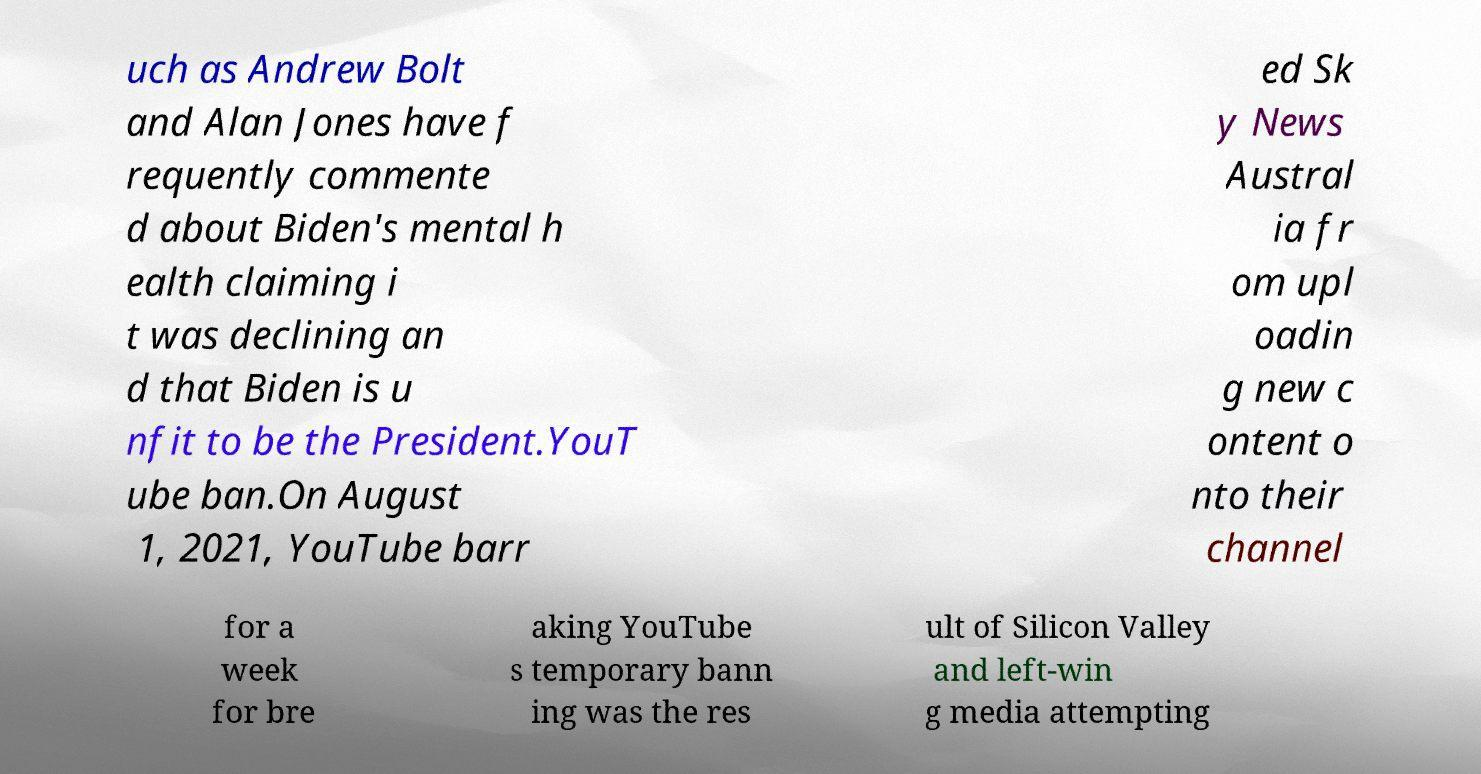Please identify and transcribe the text found in this image. uch as Andrew Bolt and Alan Jones have f requently commente d about Biden's mental h ealth claiming i t was declining an d that Biden is u nfit to be the President.YouT ube ban.On August 1, 2021, YouTube barr ed Sk y News Austral ia fr om upl oadin g new c ontent o nto their channel for a week for bre aking YouTube s temporary bann ing was the res ult of Silicon Valley and left-win g media attempting 